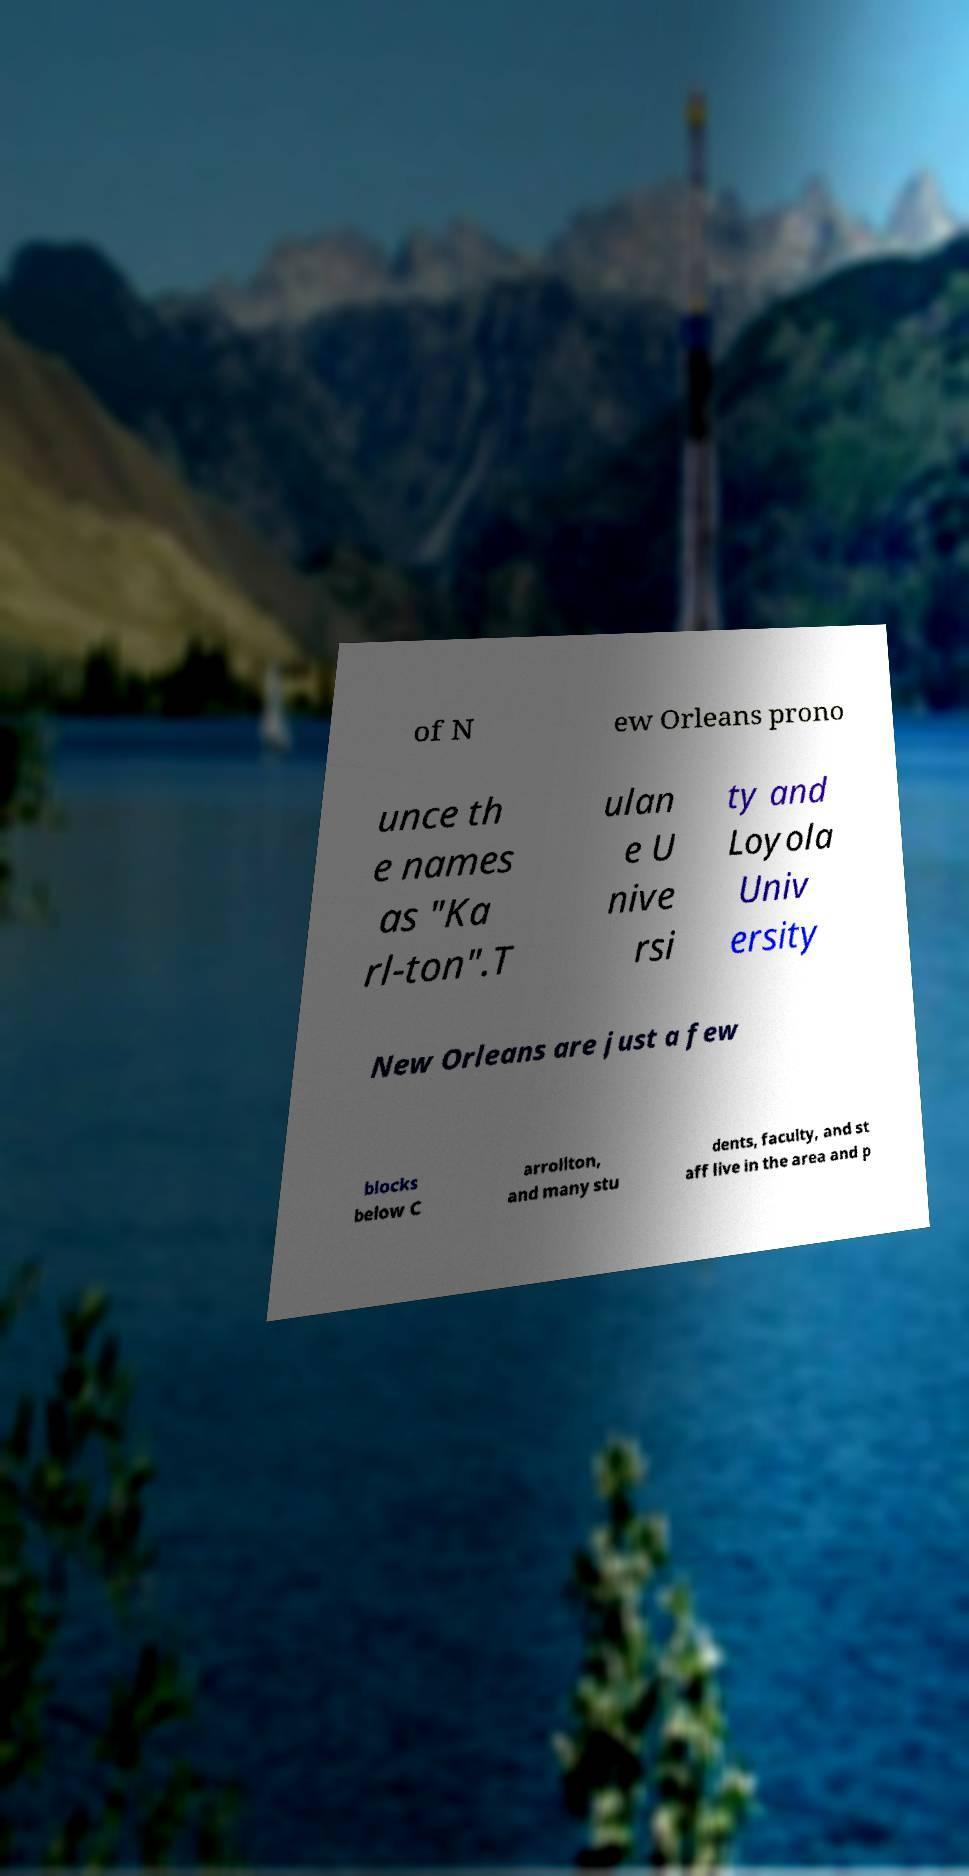For documentation purposes, I need the text within this image transcribed. Could you provide that? of N ew Orleans prono unce th e names as "Ka rl-ton".T ulan e U nive rsi ty and Loyola Univ ersity New Orleans are just a few blocks below C arrollton, and many stu dents, faculty, and st aff live in the area and p 